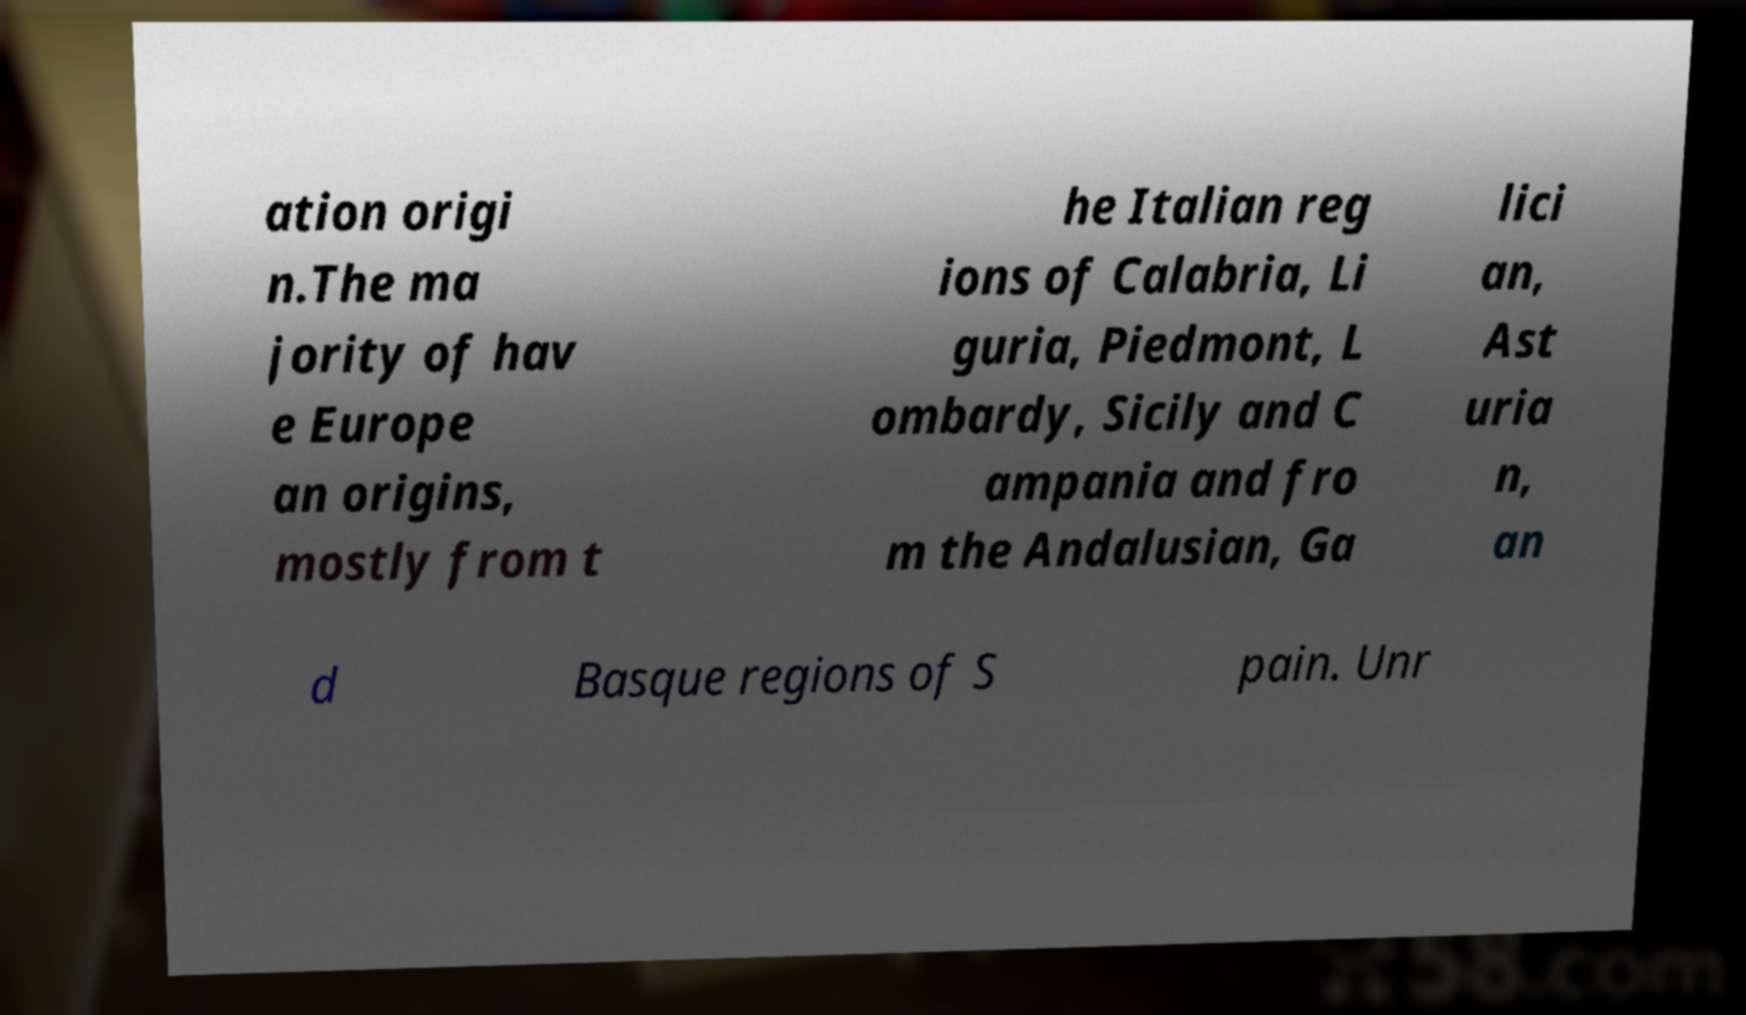Please read and relay the text visible in this image. What does it say? ation origi n.The ma jority of hav e Europe an origins, mostly from t he Italian reg ions of Calabria, Li guria, Piedmont, L ombardy, Sicily and C ampania and fro m the Andalusian, Ga lici an, Ast uria n, an d Basque regions of S pain. Unr 